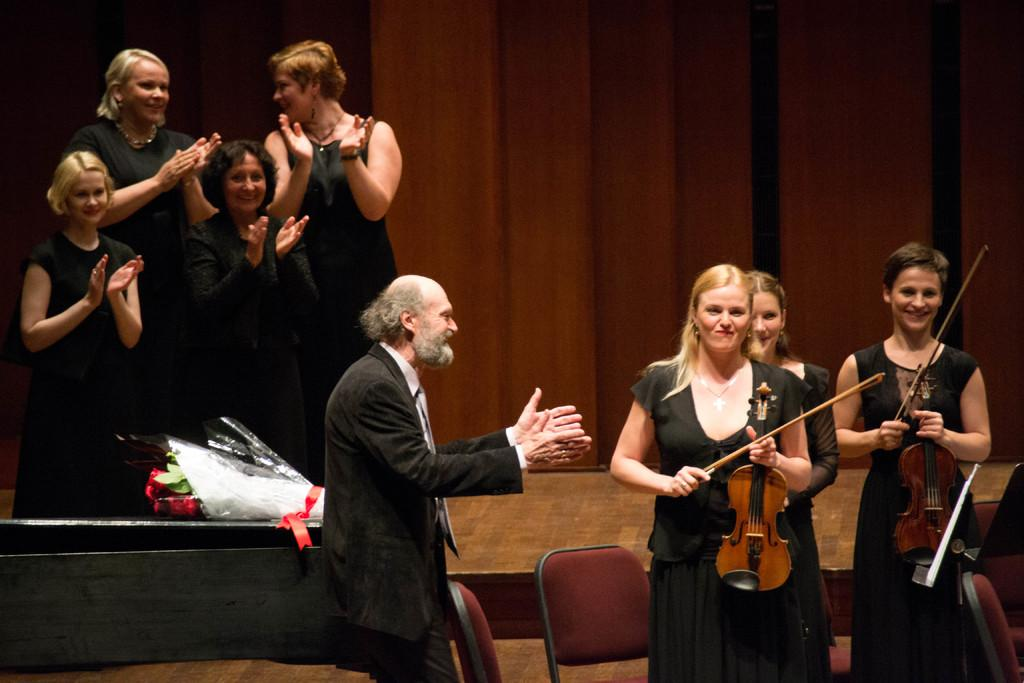What are the persons in the image doing? The persons in the image are standing and playing musical instruments. What can be seen in the background of the image? There is a stage and a curtain in the background of the image. What type of tramp can be seen jumping on the stage in the image? There is no tramp present in the image; the persons in the image are playing musical instruments on a stage. What color is the blood on the curtain in the image? There is no blood present in the image; the curtain is simply a background element. 